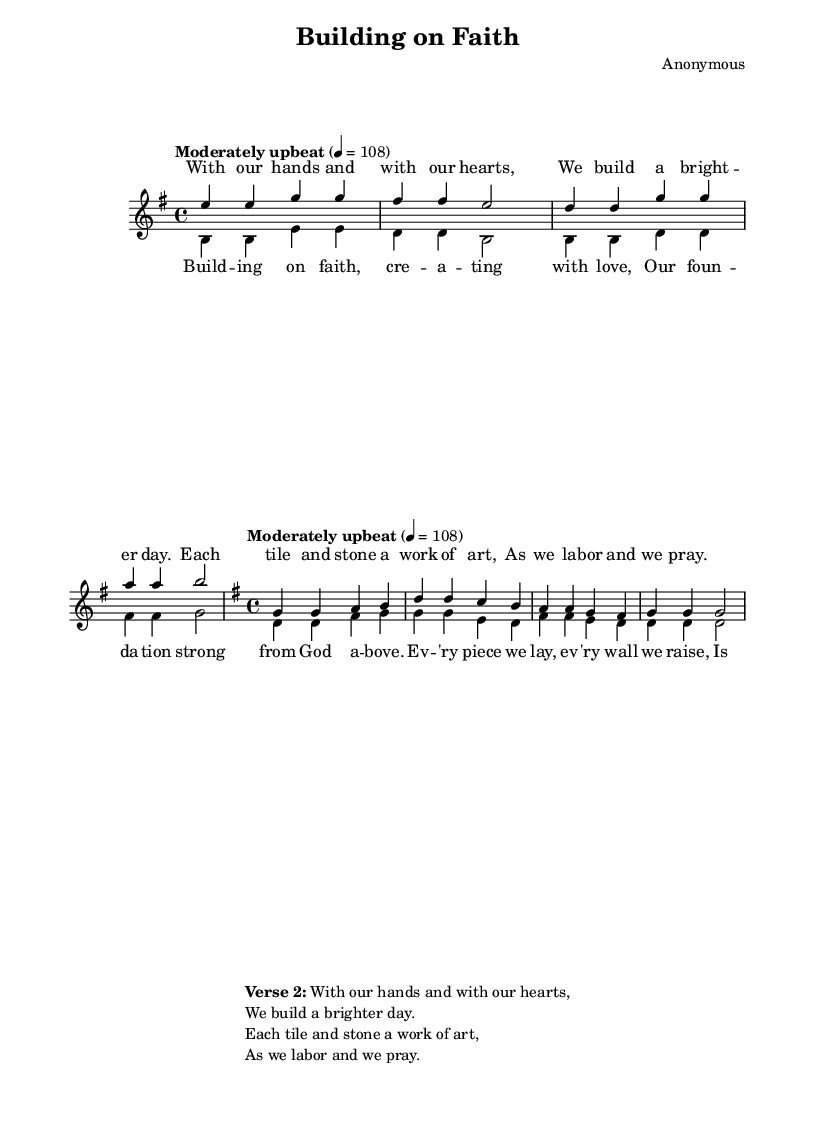What is the key signature of this music? The key signature is G major, indicated by one sharp (F#) on the sheet music.
Answer: G major What is the time signature of this music? The time signature is 4/4, which is identified at the beginning of the score.
Answer: 4/4 What is the tempo marking for this piece? The tempo marking is "Moderately upbeat," given in the tempo indication.
Answer: Moderately upbeat How many phrases are there in the chorus section? The chorus has four phrases, as indicated by the four lines of music for the chorus.
Answer: Four phrases What is the primary theme of the lyrics? The primary theme of the lyrics is the joy of creating and building with faith and love, as articulated in both verses and chorus.
Answer: Joy of creating and building In which section do the sopranos and altos sing together? The sopranos and altos sing together in the chorus section, as both vocal parts align during this part of the song.
Answer: Chorus section 